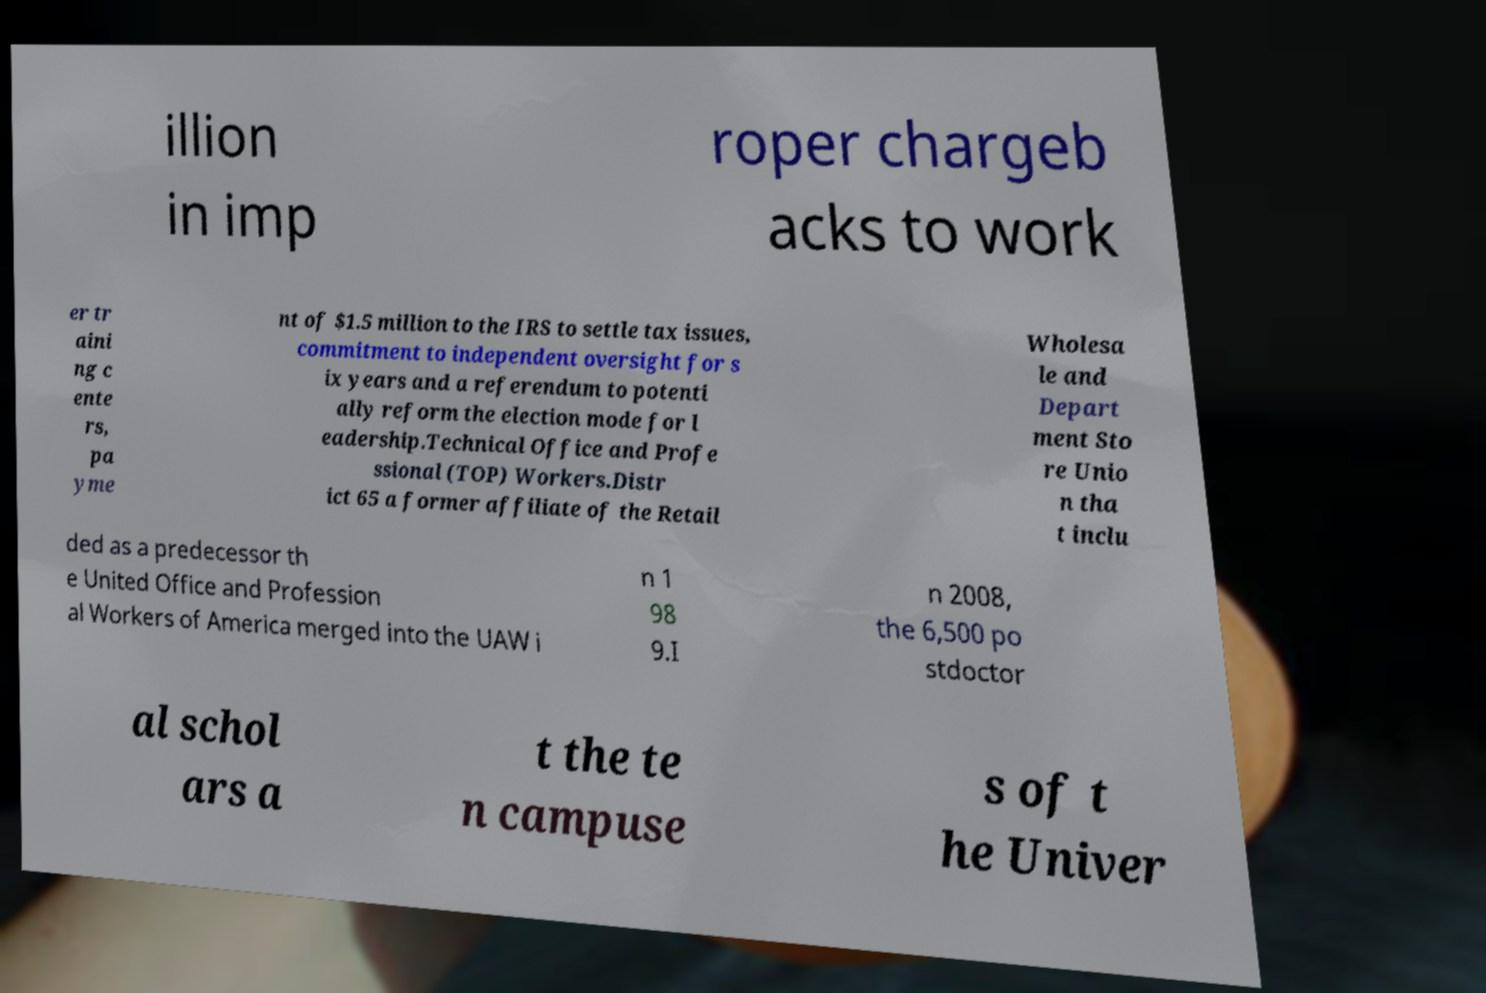Could you assist in decoding the text presented in this image and type it out clearly? illion in imp roper chargeb acks to work er tr aini ng c ente rs, pa yme nt of $1.5 million to the IRS to settle tax issues, commitment to independent oversight for s ix years and a referendum to potenti ally reform the election mode for l eadership.Technical Office and Profe ssional (TOP) Workers.Distr ict 65 a former affiliate of the Retail Wholesa le and Depart ment Sto re Unio n tha t inclu ded as a predecessor th e United Office and Profession al Workers of America merged into the UAW i n 1 98 9.I n 2008, the 6,500 po stdoctor al schol ars a t the te n campuse s of t he Univer 